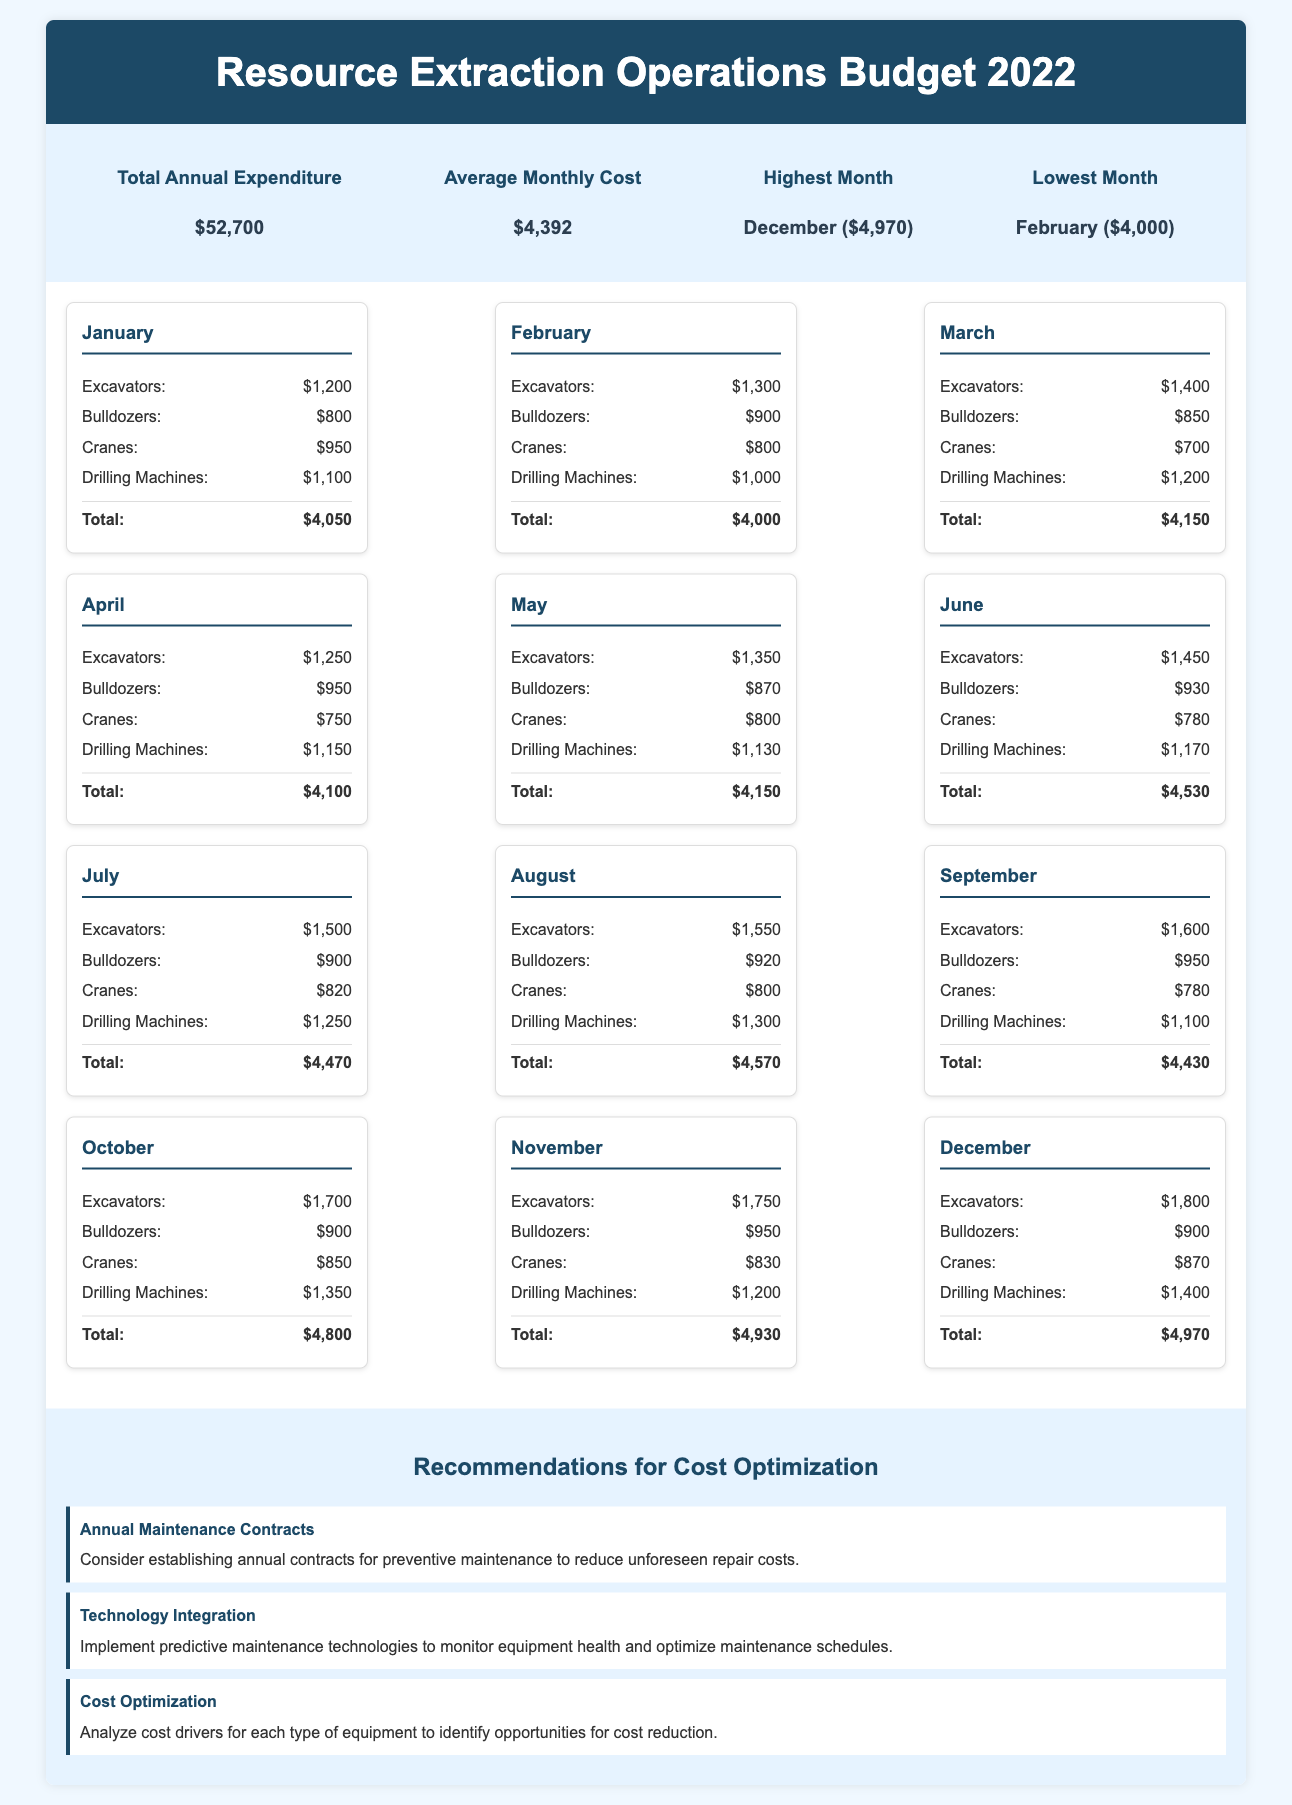What is the total annual expenditure? The total annual expenditure is stated in the budget summary section of the document.
Answer: $52,700 What is the average monthly cost? The average monthly cost is given in the budget summary section and is calculated as total annual expenditure divided by 12.
Answer: $4,392 Which month had the highest operational cost? The month with the highest operational cost is identified in the budget summary with specific details.
Answer: December ($4,970) Which month had the lowest operational cost? The month with the lowest operational cost is indicated in the budget summary with a clear figure.
Answer: February ($4,000) What was the total cost for July? The total cost for July is provided in the monthly costs section with detailed breakdowns of the machinery costs.
Answer: $4,470 How much did the excavators cost in September? The cost specifically for excavators in September is stated within the monthly cost details.
Answer: $1,600 What is one recommendation given for cost optimization? The document includes recommendations for cost optimization, which can be found in the recommendations section.
Answer: Annual Maintenance Contracts How much did drilling machines cost in October? The cost of drilling machines in October is specified in the monthly costs section.
Answer: $1,350 What was the total monthly cost for March? The total monthly cost for March is summarized in the specific month card related to March in the document.
Answer: $4,150 